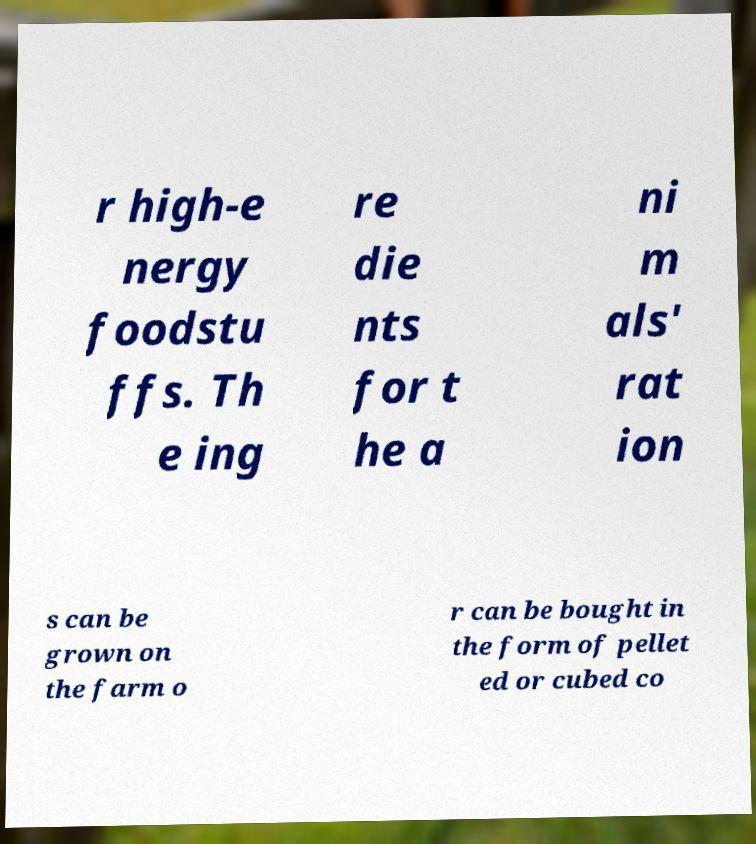Please identify and transcribe the text found in this image. r high-e nergy foodstu ffs. Th e ing re die nts for t he a ni m als' rat ion s can be grown on the farm o r can be bought in the form of pellet ed or cubed co 